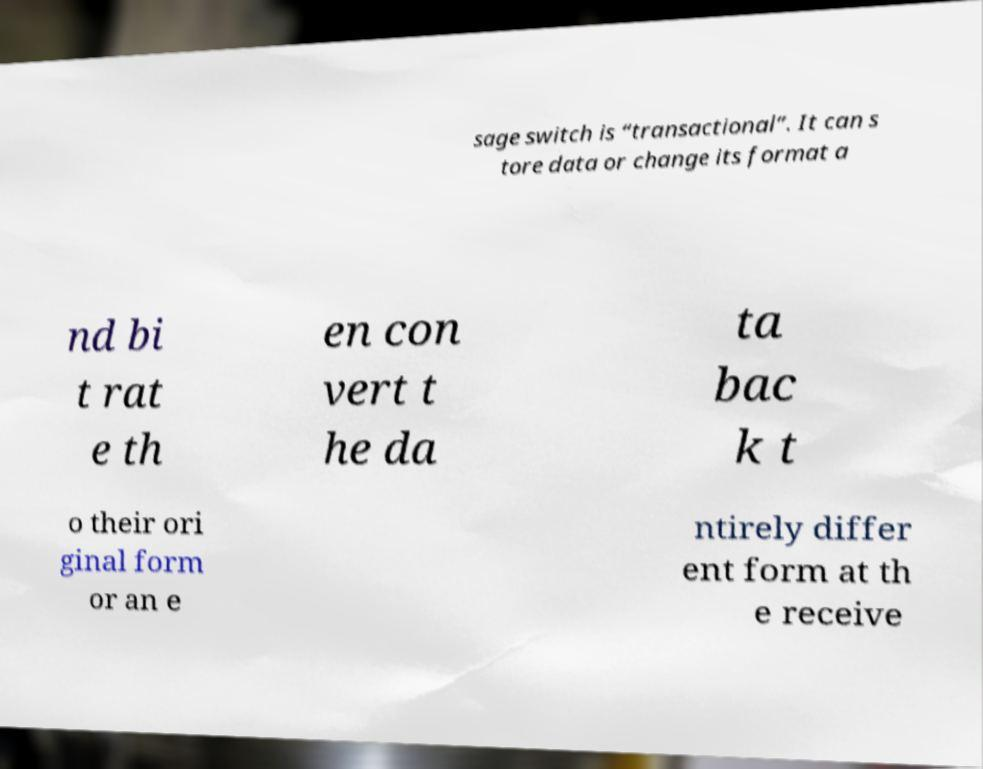Please read and relay the text visible in this image. What does it say? sage switch is “transactional”. It can s tore data or change its format a nd bi t rat e th en con vert t he da ta bac k t o their ori ginal form or an e ntirely differ ent form at th e receive 